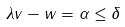Convert formula to latex. <formula><loc_0><loc_0><loc_500><loc_500>\| \lambda v - w \| = \alpha \leq \delta</formula> 